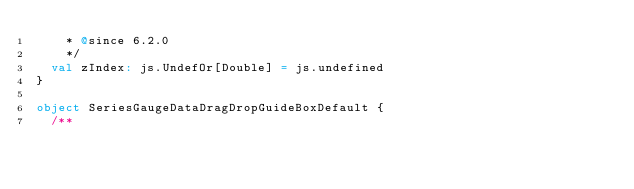Convert code to text. <code><loc_0><loc_0><loc_500><loc_500><_Scala_>    * @since 6.2.0
    */
  val zIndex: js.UndefOr[Double] = js.undefined
}

object SeriesGaugeDataDragDropGuideBoxDefault {
  /**</code> 